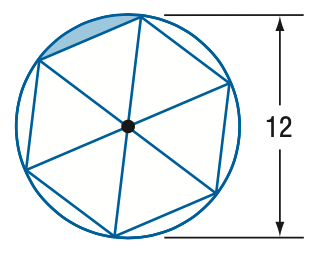Question: Find the area of the shaded region. Assume the inscribed polygon is regular.
Choices:
A. 3.3
B. 6.5
C. 12.3
D. 19.6
Answer with the letter. Answer: A 